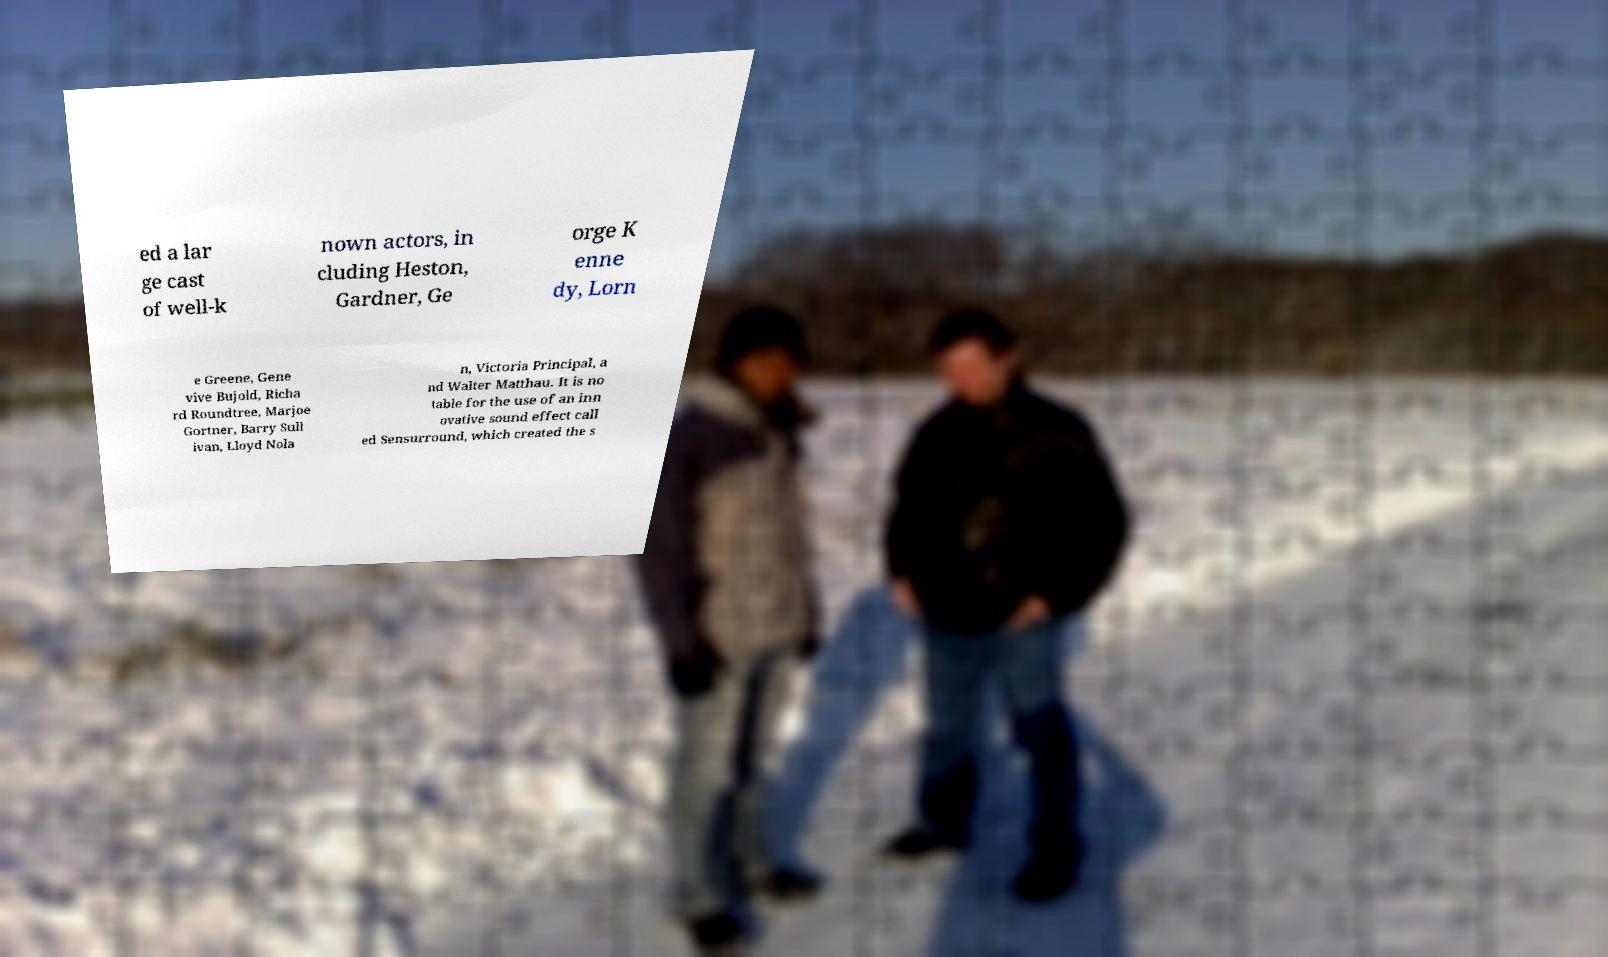Please identify and transcribe the text found in this image. ed a lar ge cast of well-k nown actors, in cluding Heston, Gardner, Ge orge K enne dy, Lorn e Greene, Gene vive Bujold, Richa rd Roundtree, Marjoe Gortner, Barry Sull ivan, Lloyd Nola n, Victoria Principal, a nd Walter Matthau. It is no table for the use of an inn ovative sound effect call ed Sensurround, which created the s 